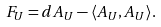Convert formula to latex. <formula><loc_0><loc_0><loc_500><loc_500>F _ { U } = d A _ { U } - \langle A _ { U } , A _ { U } \rangle .</formula> 